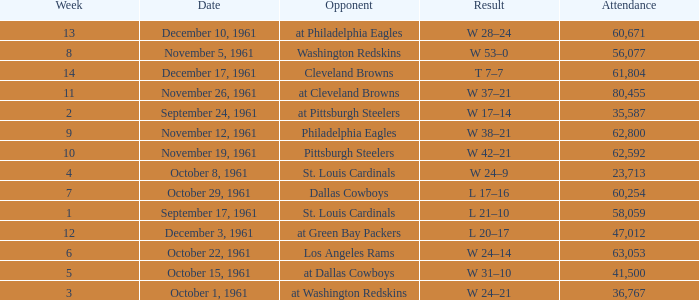Which Attendance has a Date of november 19, 1961? 62592.0. 